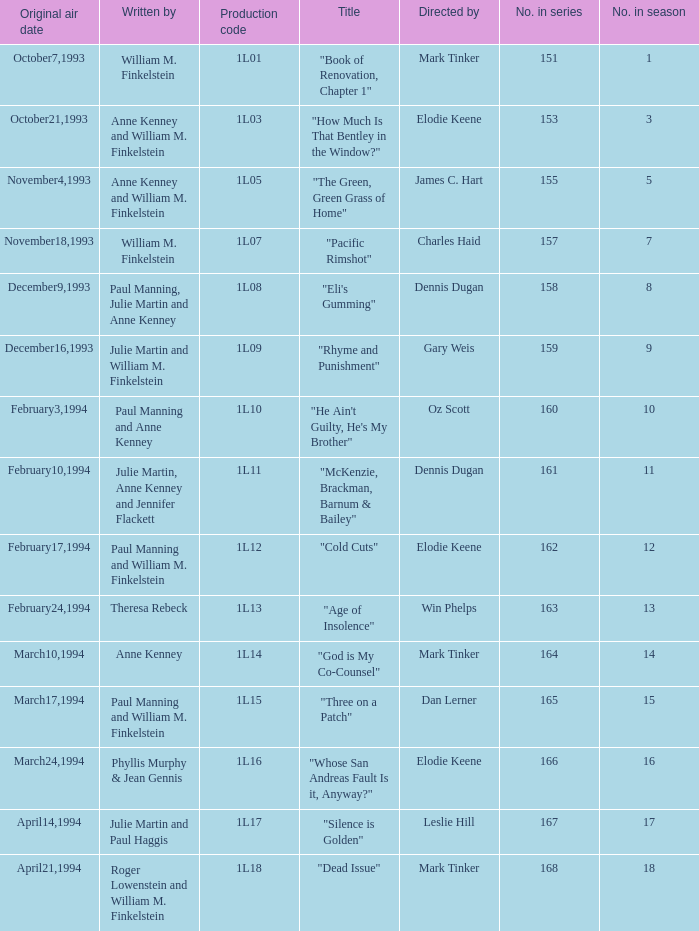Name the most number in season for leslie hill 17.0. 